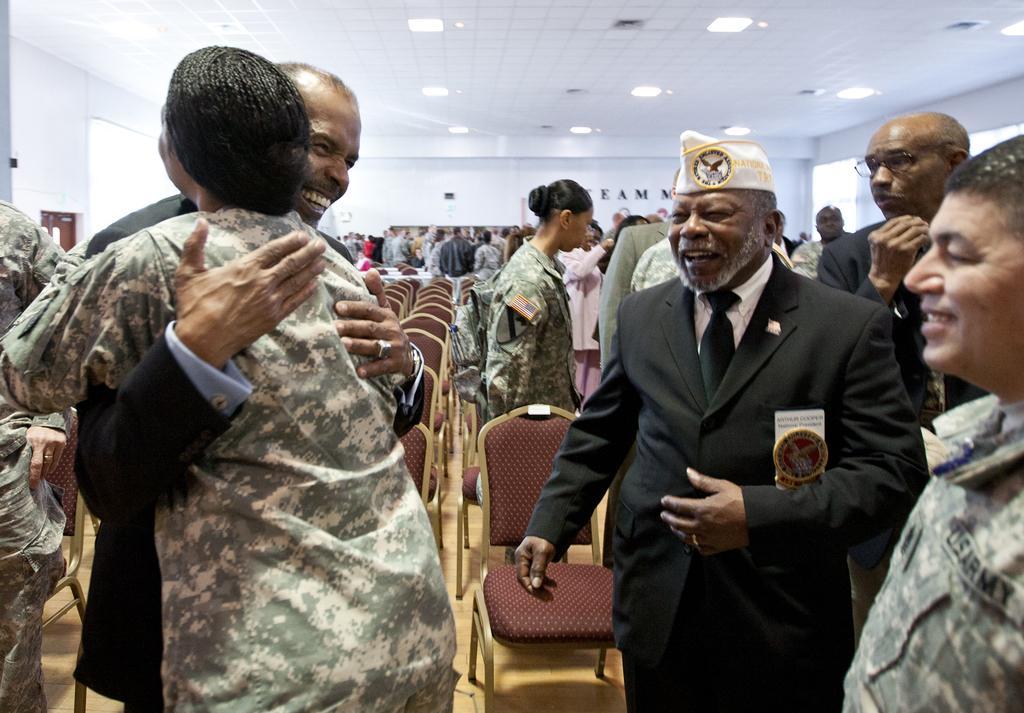Can you describe this image briefly? In this image we can see a group of people standing. In that a man and a woman are hugging each other. On the backside we can see some chairs, a group of people standing, a wall and a roof with some ceiling lights. 